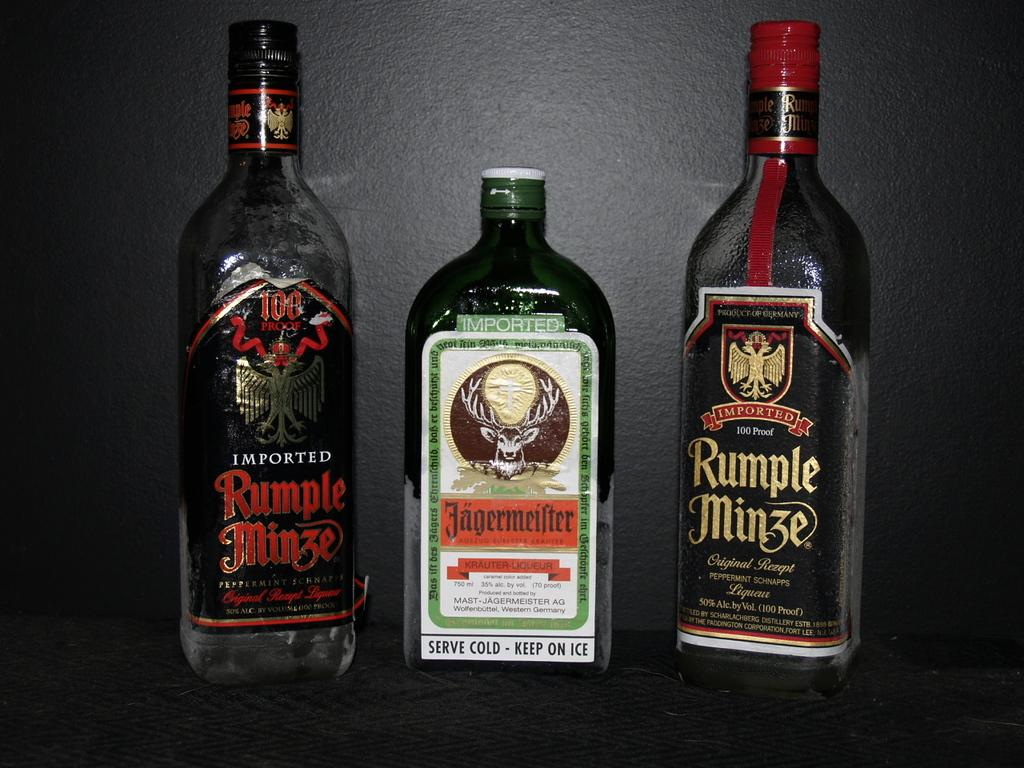Provide a one-sentence caption for the provided image. Three bottles of alcohol with two Rumple Minze on the outer part. 